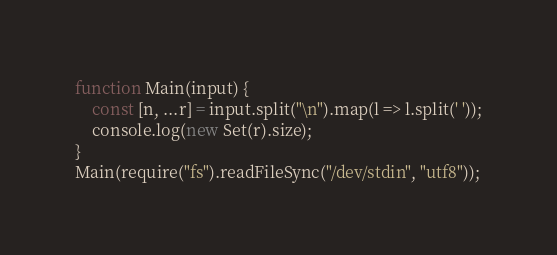<code> <loc_0><loc_0><loc_500><loc_500><_TypeScript_>function Main(input) {
	const [n, ...r] = input.split("\n").map(l => l.split(' '));
	console.log(new Set(r).size);
}
Main(require("fs").readFileSync("/dev/stdin", "utf8"));</code> 